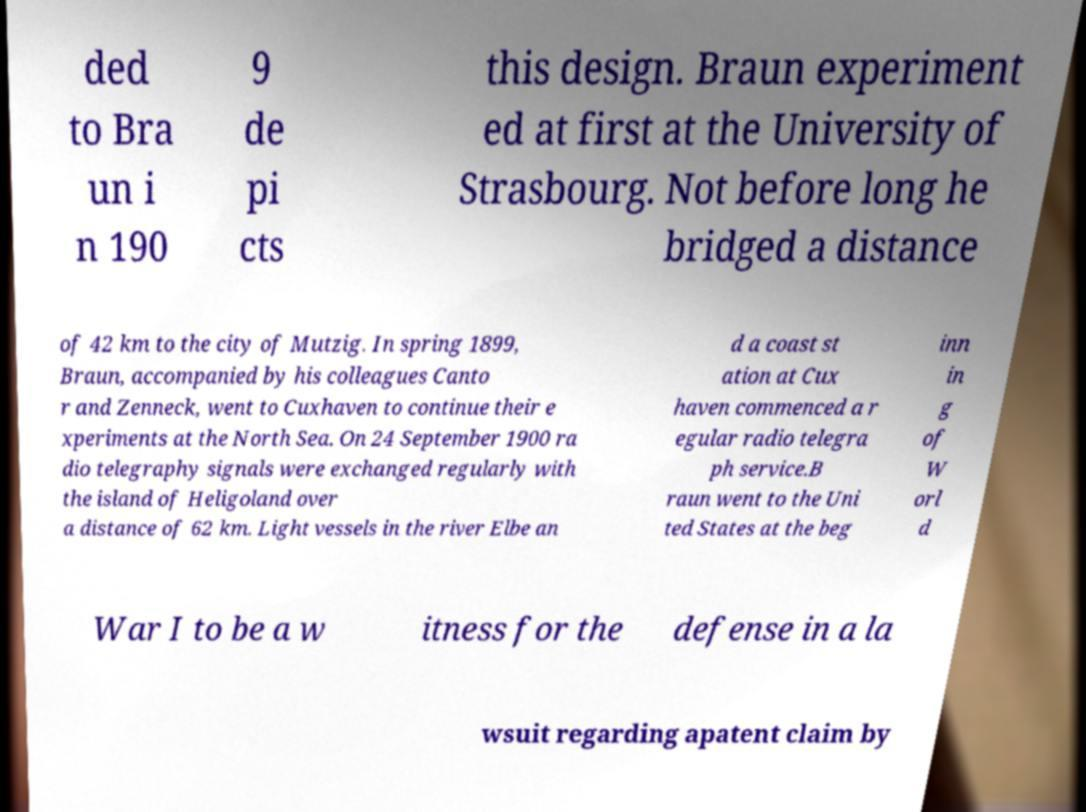I need the written content from this picture converted into text. Can you do that? ded to Bra un i n 190 9 de pi cts this design. Braun experiment ed at first at the University of Strasbourg. Not before long he bridged a distance of 42 km to the city of Mutzig. In spring 1899, Braun, accompanied by his colleagues Canto r and Zenneck, went to Cuxhaven to continue their e xperiments at the North Sea. On 24 September 1900 ra dio telegraphy signals were exchanged regularly with the island of Heligoland over a distance of 62 km. Light vessels in the river Elbe an d a coast st ation at Cux haven commenced a r egular radio telegra ph service.B raun went to the Uni ted States at the beg inn in g of W orl d War I to be a w itness for the defense in a la wsuit regarding apatent claim by 